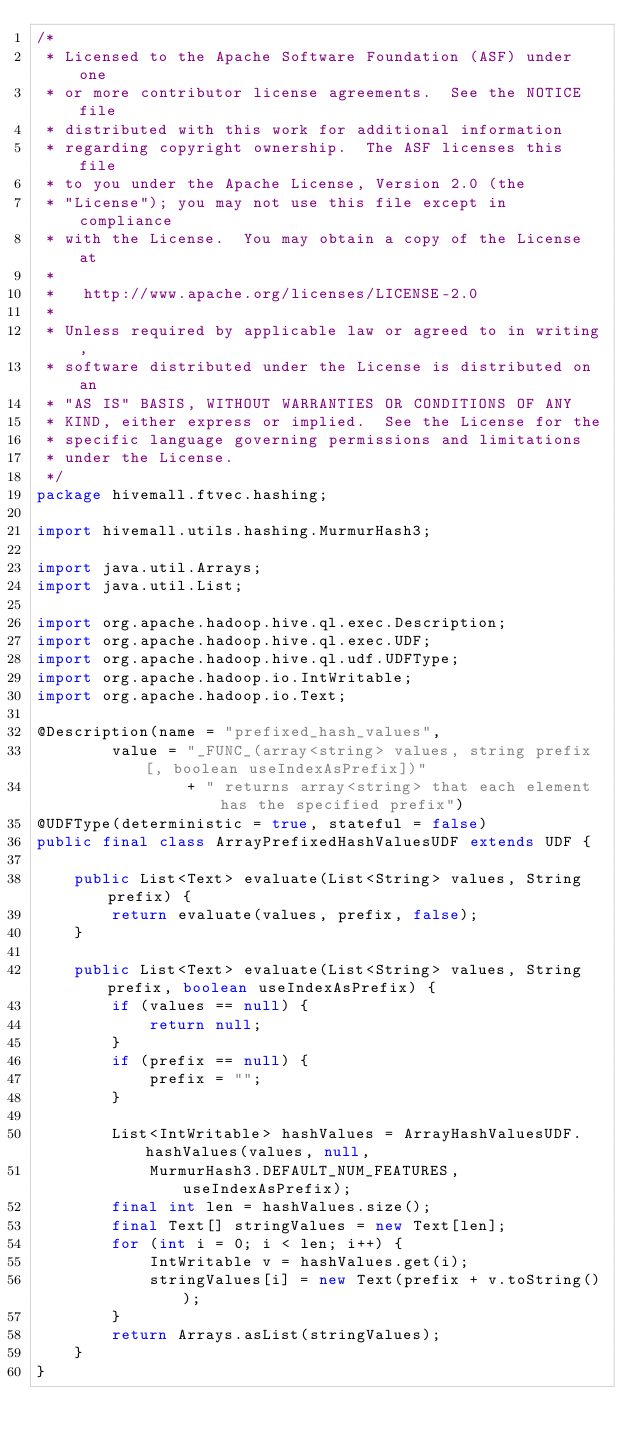Convert code to text. <code><loc_0><loc_0><loc_500><loc_500><_Java_>/*
 * Licensed to the Apache Software Foundation (ASF) under one
 * or more contributor license agreements.  See the NOTICE file
 * distributed with this work for additional information
 * regarding copyright ownership.  The ASF licenses this file
 * to you under the Apache License, Version 2.0 (the
 * "License"); you may not use this file except in compliance
 * with the License.  You may obtain a copy of the License at
 *
 *   http://www.apache.org/licenses/LICENSE-2.0
 *
 * Unless required by applicable law or agreed to in writing,
 * software distributed under the License is distributed on an
 * "AS IS" BASIS, WITHOUT WARRANTIES OR CONDITIONS OF ANY
 * KIND, either express or implied.  See the License for the
 * specific language governing permissions and limitations
 * under the License.
 */
package hivemall.ftvec.hashing;

import hivemall.utils.hashing.MurmurHash3;

import java.util.Arrays;
import java.util.List;

import org.apache.hadoop.hive.ql.exec.Description;
import org.apache.hadoop.hive.ql.exec.UDF;
import org.apache.hadoop.hive.ql.udf.UDFType;
import org.apache.hadoop.io.IntWritable;
import org.apache.hadoop.io.Text;

@Description(name = "prefixed_hash_values",
        value = "_FUNC_(array<string> values, string prefix [, boolean useIndexAsPrefix])"
                + " returns array<string> that each element has the specified prefix")
@UDFType(deterministic = true, stateful = false)
public final class ArrayPrefixedHashValuesUDF extends UDF {

    public List<Text> evaluate(List<String> values, String prefix) {
        return evaluate(values, prefix, false);
    }

    public List<Text> evaluate(List<String> values, String prefix, boolean useIndexAsPrefix) {
        if (values == null) {
            return null;
        }
        if (prefix == null) {
            prefix = "";
        }

        List<IntWritable> hashValues = ArrayHashValuesUDF.hashValues(values, null,
            MurmurHash3.DEFAULT_NUM_FEATURES, useIndexAsPrefix);
        final int len = hashValues.size();
        final Text[] stringValues = new Text[len];
        for (int i = 0; i < len; i++) {
            IntWritable v = hashValues.get(i);
            stringValues[i] = new Text(prefix + v.toString());
        }
        return Arrays.asList(stringValues);
    }
}
</code> 